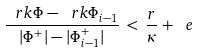Convert formula to latex. <formula><loc_0><loc_0><loc_500><loc_500>\frac { \ r k \Phi - \ r k \Phi _ { i - 1 } } { | \Phi ^ { + } | - | \Phi ^ { + } _ { i - 1 } | } \, < \, \frac { r } { \kappa } + \ e</formula> 